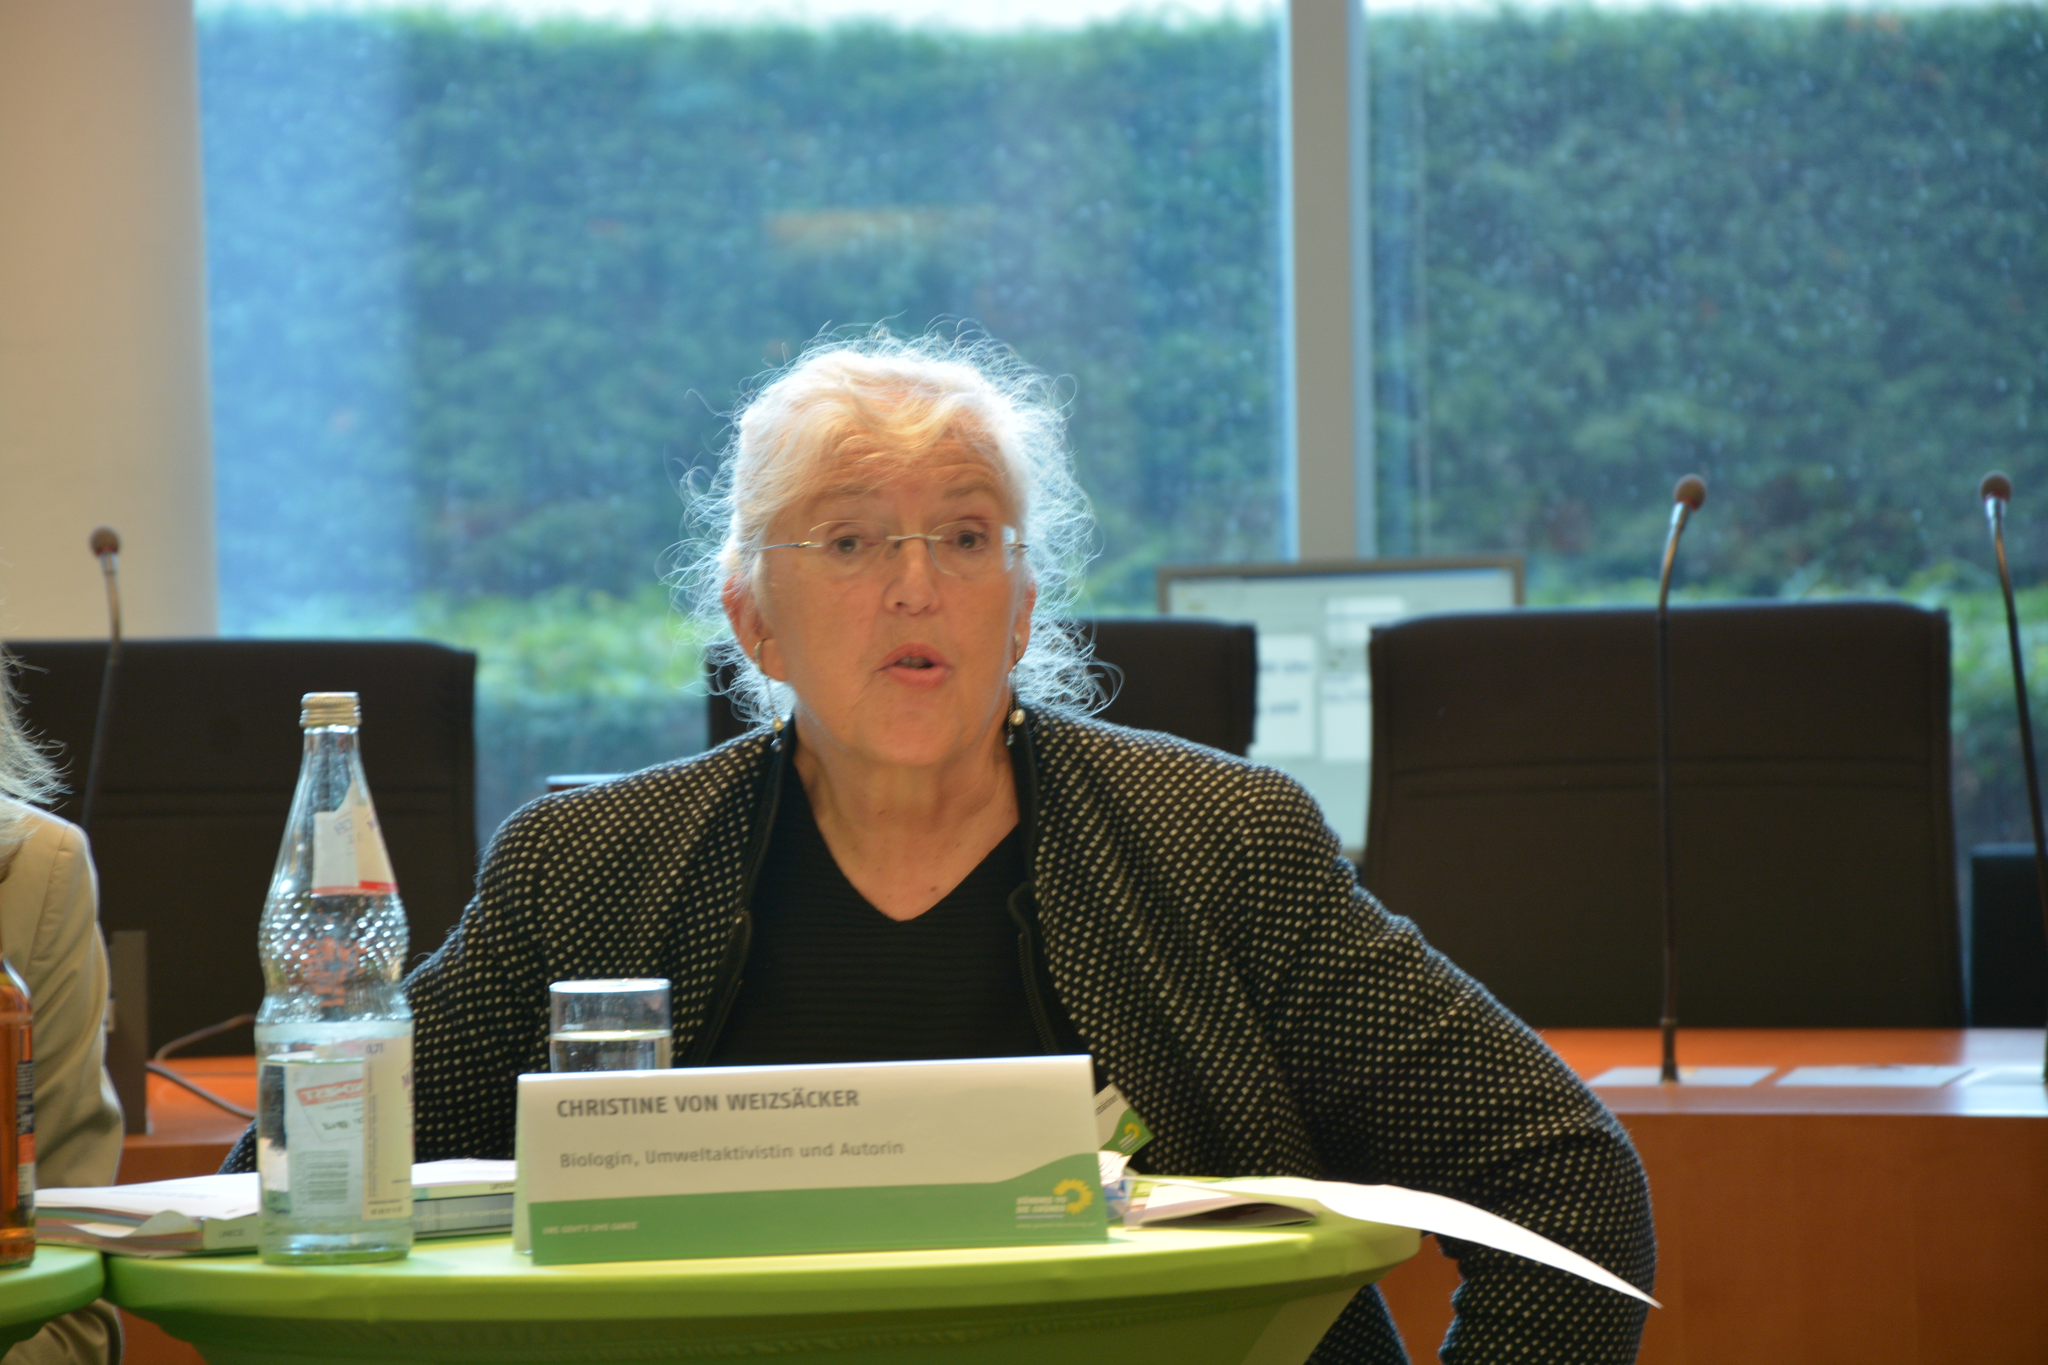Provide a one-sentence caption for the provided image. a woman standing behind a small sign that says 'christine von weizsacker'. 